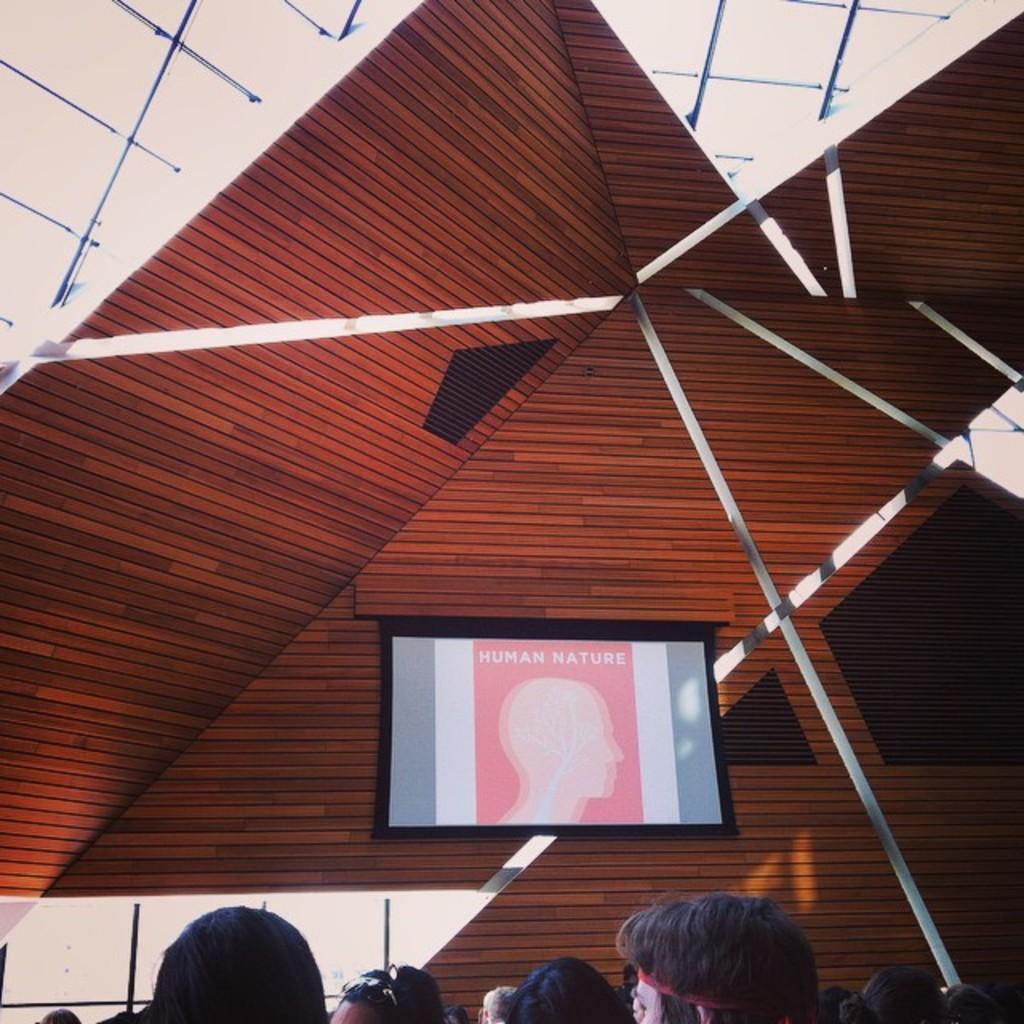Please provide a concise description of this image. In this image we can see the heads of people, there is a screen with image and text on it, also we can see the roof, and windows. 